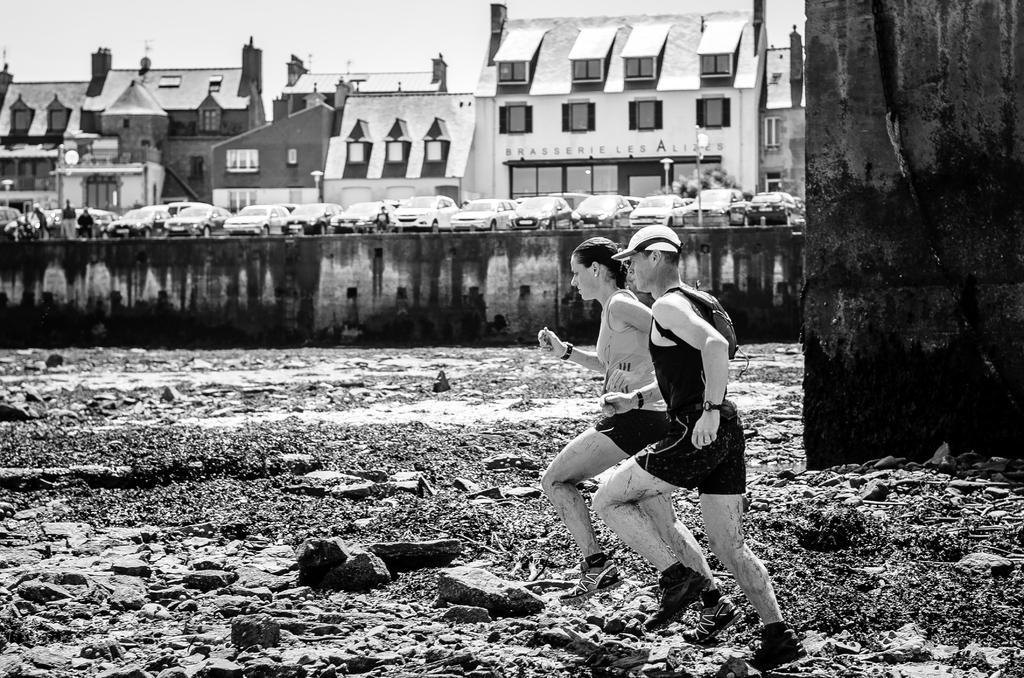Please provide a concise description of this image. In this image we can see two people running on the ground and in the background there are a few buildings and cars parked in front of the building and sky in the background. 